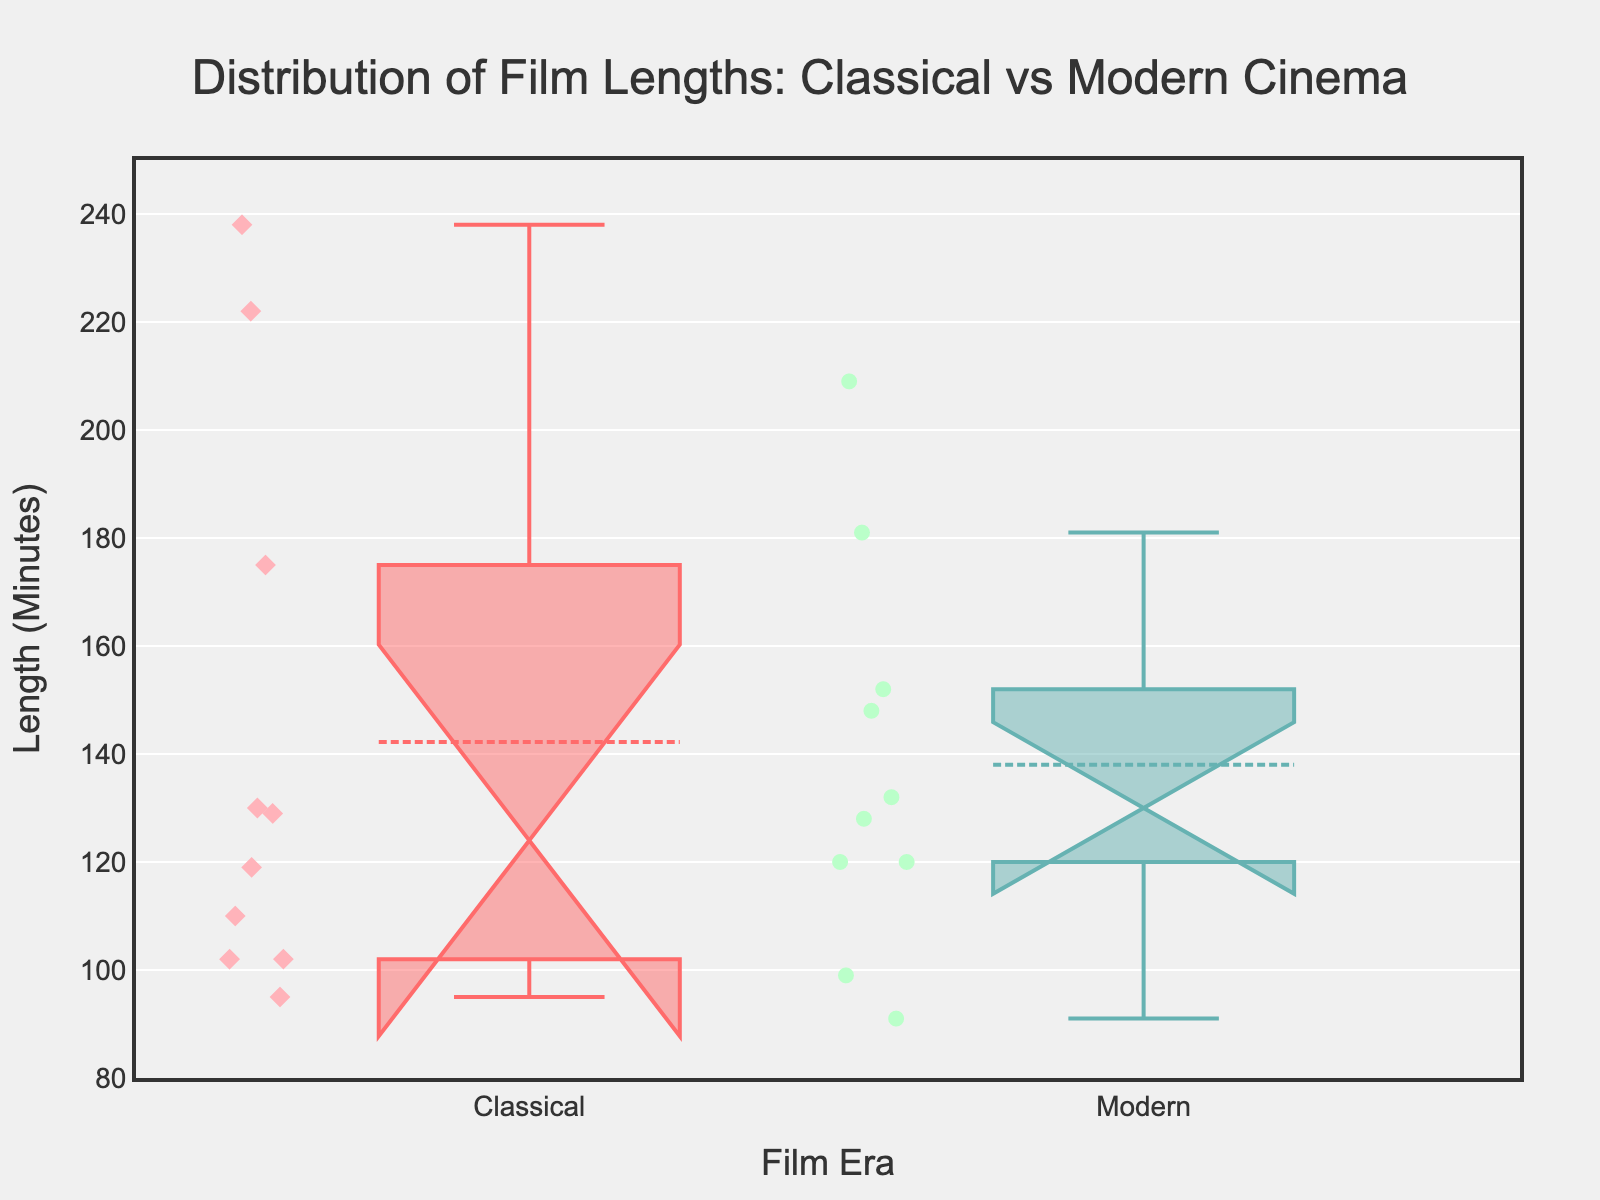What's the title of the plot? The title is displayed prominently at the top of the plot.
Answer: Distribution of Film Lengths: Classical vs Modern Cinema What's the average film length in the Classical films era? The plot shows that the mean is displayed inside the boxplot for both groups.
Answer: Approximately 142 minutes Which era has a wider interquartile range (IQR) for film lengths? The width of the box (IQR) represents the range between the first and third quartiles. The Classical box is narrower than the Modern box.
Answer: Modern Do Classical films tend to be shorter or longer than Modern films? Comparing the medians and the spread of each boxplot: Classical films show a lower median and overall shorter range compared to Modern films.
Answer: Shorter What is the range of film lengths for Classical films? The range extends from the minimum to the maximum data point within the Classical boxplot, which can be visually tracked from the lower whisker to the upper whisker.
Answer: 95 to 238 minutes Is there an overlap between the notches of the Classical and Modern film lengths, indicating similar medians? The notches in the boxplots indicate the confidence interval around the median. If notches do not overlap, medians are significantly different. Here, the notches do not overlap.
Answer: No Which era contains the film with the longest length? The longest film length data point is the highest whisker or outlier point in both plots. The Modern era has the longest film.
Answer: Modern What can you infer about the distribution of film lengths from the Classical era relative to Modern films? Analyzing the boxplots, we see the Classical era has less variability and shorter average length whereas the Modern films show more variability and a longer average length.
Answer: Classical films are generally shorter and more consistent in length Which era has a higher median film length? The horizontal line inside each box represents the median. Comparing these lines, the median film length of Modern films is higher than that of Classical films.
Answer: Modern 